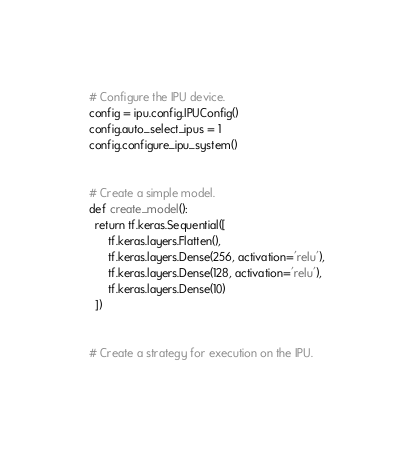Convert code to text. <code><loc_0><loc_0><loc_500><loc_500><_Python_>
# Configure the IPU device.
config = ipu.config.IPUConfig()
config.auto_select_ipus = 1
config.configure_ipu_system()


# Create a simple model.
def create_model():
  return tf.keras.Sequential([
      tf.keras.layers.Flatten(),
      tf.keras.layers.Dense(256, activation='relu'),
      tf.keras.layers.Dense(128, activation='relu'),
      tf.keras.layers.Dense(10)
  ])


# Create a strategy for execution on the IPU.</code> 